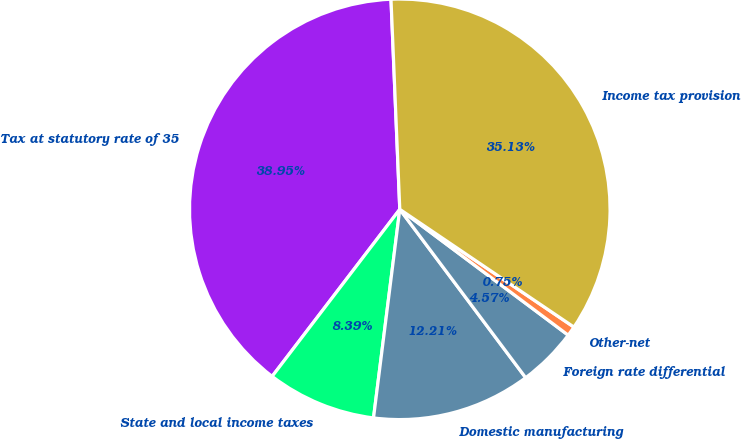<chart> <loc_0><loc_0><loc_500><loc_500><pie_chart><fcel>Tax at statutory rate of 35<fcel>State and local income taxes<fcel>Domestic manufacturing<fcel>Foreign rate differential<fcel>Other-net<fcel>Income tax provision<nl><fcel>38.95%<fcel>8.39%<fcel>12.21%<fcel>4.57%<fcel>0.75%<fcel>35.13%<nl></chart> 